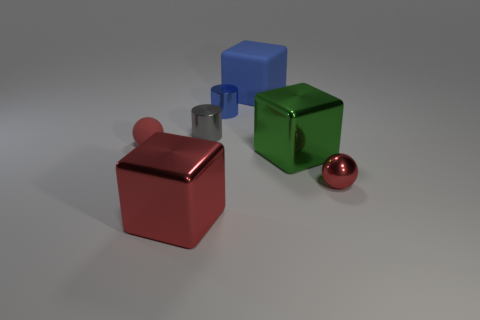There is a cylinder that is the same color as the rubber cube; what material is it?
Make the answer very short. Metal. How many other things are the same shape as the large green object?
Offer a very short reply. 2. What is the color of the big shiny block to the left of the big blue rubber thing that is left of the red metallic object behind the large red shiny cube?
Your answer should be compact. Red. What number of large things are there?
Provide a succinct answer. 3. What number of large objects are either blocks or balls?
Provide a succinct answer. 3. What is the shape of the red shiny object that is the same size as the blue rubber thing?
Keep it short and to the point. Cube. What is the material of the tiny ball behind the metallic cube that is on the right side of the small blue metal object?
Provide a succinct answer. Rubber. Do the red rubber sphere and the green cube have the same size?
Offer a terse response. No. What number of objects are either things in front of the red rubber ball or big cyan cylinders?
Keep it short and to the point. 3. The large shiny thing that is in front of the red metallic object that is right of the tiny blue shiny cylinder is what shape?
Your answer should be compact. Cube. 